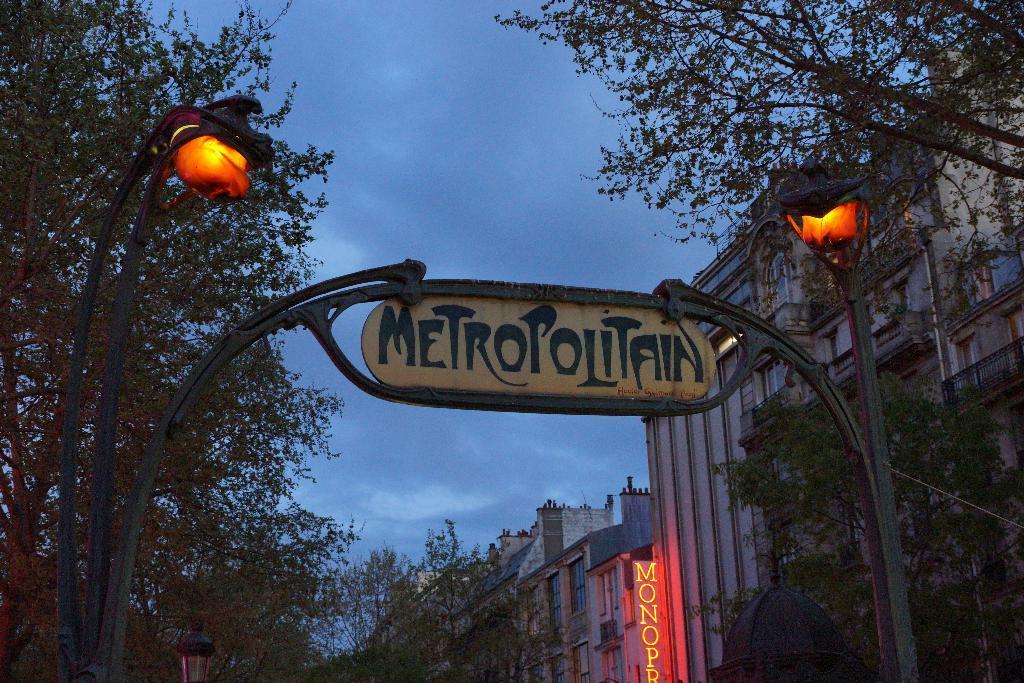How would you summarize this image in a sentence or two? In the center of the image an arch is there. On the right side of the image we can see electric pole light, buildings, trees are there. At the top of the image clouds are present in the sky. 